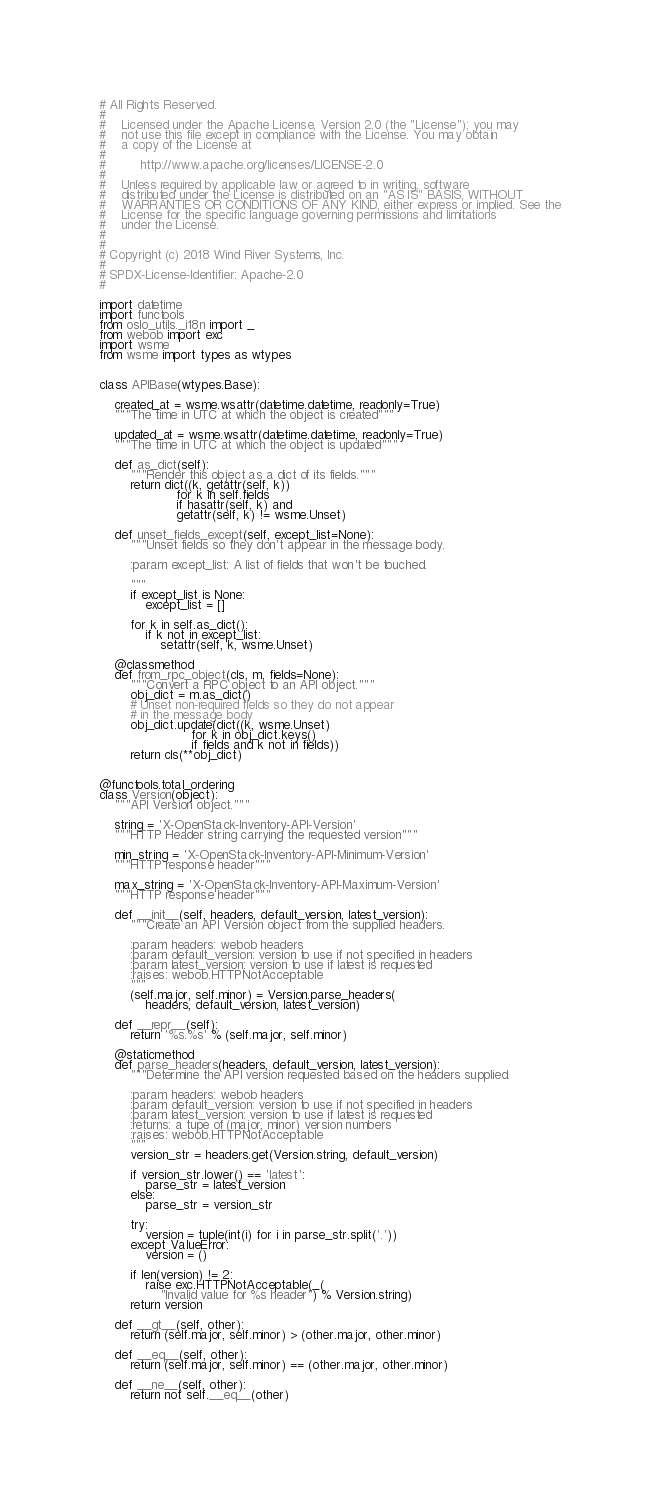<code> <loc_0><loc_0><loc_500><loc_500><_Python_># All Rights Reserved.
#
#    Licensed under the Apache License, Version 2.0 (the "License"); you may
#    not use this file except in compliance with the License. You may obtain
#    a copy of the License at
#
#         http://www.apache.org/licenses/LICENSE-2.0
#
#    Unless required by applicable law or agreed to in writing, software
#    distributed under the License is distributed on an "AS IS" BASIS, WITHOUT
#    WARRANTIES OR CONDITIONS OF ANY KIND, either express or implied. See the
#    License for the specific language governing permissions and limitations
#    under the License.
#
#
# Copyright (c) 2018 Wind River Systems, Inc.
#
# SPDX-License-Identifier: Apache-2.0
#

import datetime
import functools
from oslo_utils._i18n import _
from webob import exc
import wsme
from wsme import types as wtypes


class APIBase(wtypes.Base):

    created_at = wsme.wsattr(datetime.datetime, readonly=True)
    """The time in UTC at which the object is created"""

    updated_at = wsme.wsattr(datetime.datetime, readonly=True)
    """The time in UTC at which the object is updated"""

    def as_dict(self):
        """Render this object as a dict of its fields."""
        return dict((k, getattr(self, k))
                    for k in self.fields
                    if hasattr(self, k) and
                    getattr(self, k) != wsme.Unset)

    def unset_fields_except(self, except_list=None):
        """Unset fields so they don't appear in the message body.

        :param except_list: A list of fields that won't be touched.

        """
        if except_list is None:
            except_list = []

        for k in self.as_dict():
            if k not in except_list:
                setattr(self, k, wsme.Unset)

    @classmethod
    def from_rpc_object(cls, m, fields=None):
        """Convert a RPC object to an API object."""
        obj_dict = m.as_dict()
        # Unset non-required fields so they do not appear
        # in the message body
        obj_dict.update(dict((k, wsme.Unset)
                        for k in obj_dict.keys()
                        if fields and k not in fields))
        return cls(**obj_dict)


@functools.total_ordering
class Version(object):
    """API Version object."""

    string = 'X-OpenStack-Inventory-API-Version'
    """HTTP Header string carrying the requested version"""

    min_string = 'X-OpenStack-Inventory-API-Minimum-Version'
    """HTTP response header"""

    max_string = 'X-OpenStack-Inventory-API-Maximum-Version'
    """HTTP response header"""

    def __init__(self, headers, default_version, latest_version):
        """Create an API Version object from the supplied headers.

        :param headers: webob headers
        :param default_version: version to use if not specified in headers
        :param latest_version: version to use if latest is requested
        :raises: webob.HTTPNotAcceptable
        """
        (self.major, self.minor) = Version.parse_headers(
            headers, default_version, latest_version)

    def __repr__(self):
        return '%s.%s' % (self.major, self.minor)

    @staticmethod
    def parse_headers(headers, default_version, latest_version):
        """Determine the API version requested based on the headers supplied.

        :param headers: webob headers
        :param default_version: version to use if not specified in headers
        :param latest_version: version to use if latest is requested
        :returns: a tupe of (major, minor) version numbers
        :raises: webob.HTTPNotAcceptable
        """
        version_str = headers.get(Version.string, default_version)

        if version_str.lower() == 'latest':
            parse_str = latest_version
        else:
            parse_str = version_str

        try:
            version = tuple(int(i) for i in parse_str.split('.'))
        except ValueError:
            version = ()

        if len(version) != 2:
            raise exc.HTTPNotAcceptable(_(
                "Invalid value for %s header") % Version.string)
        return version

    def __gt__(self, other):
        return (self.major, self.minor) > (other.major, other.minor)

    def __eq__(self, other):
        return (self.major, self.minor) == (other.major, other.minor)

    def __ne__(self, other):
        return not self.__eq__(other)
</code> 